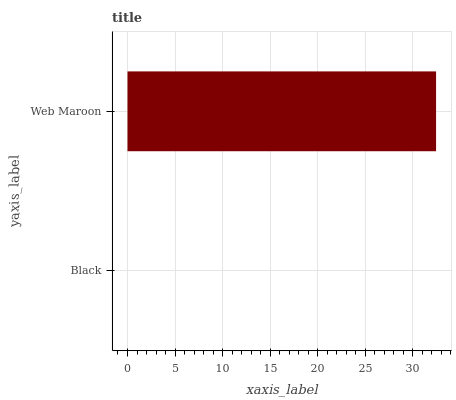Is Black the minimum?
Answer yes or no. Yes. Is Web Maroon the maximum?
Answer yes or no. Yes. Is Web Maroon the minimum?
Answer yes or no. No. Is Web Maroon greater than Black?
Answer yes or no. Yes. Is Black less than Web Maroon?
Answer yes or no. Yes. Is Black greater than Web Maroon?
Answer yes or no. No. Is Web Maroon less than Black?
Answer yes or no. No. Is Web Maroon the high median?
Answer yes or no. Yes. Is Black the low median?
Answer yes or no. Yes. Is Black the high median?
Answer yes or no. No. Is Web Maroon the low median?
Answer yes or no. No. 